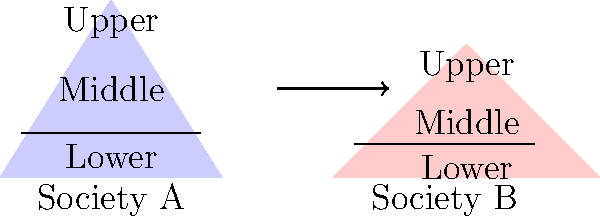Given the pyramid diagrams representing the social structures of two fictional societies, A and B, what can be inferred about the relative size and distribution of social classes between these societies? To analyze the social structures represented by these pyramid diagrams:

1. Shape analysis:
   - Society A has a more triangular shape
   - Society B has a wider, flatter shape

2. Relative class sizes:
   - In Society A:
     * The upper class occupies a smaller area at the top
     * The middle class is represented by a larger middle section
     * The lower class forms a broad base
   - In Society B:
     * The upper class occupies a larger area at the top
     * The middle class is relatively smaller
     * The lower class, while still the largest, is proportionally smaller than in Society A

3. Interpretation:
   - Society A likely has:
     * A smaller elite class
     * A substantial middle class
     * A large lower class
   - Society B likely has:
     * A larger elite class
     * A smaller middle class
     * A lower class that, while still the largest, is less dominant than in Society A

4. Comparative analysis:
   - Society B appears to have greater inequality, with more concentration of power/resources at the top
   - Society A seems to have a more evenly distributed social structure, with a stronger middle class

5. Sociological implications:
   - Society A may have more social mobility and a more stable social order
   - Society B may face more social tensions due to the larger gap between upper and lower classes
Answer: Society B has greater social inequality with a larger upper class and smaller middle class, while Society A has a more evenly distributed social structure with a stronger middle class. 